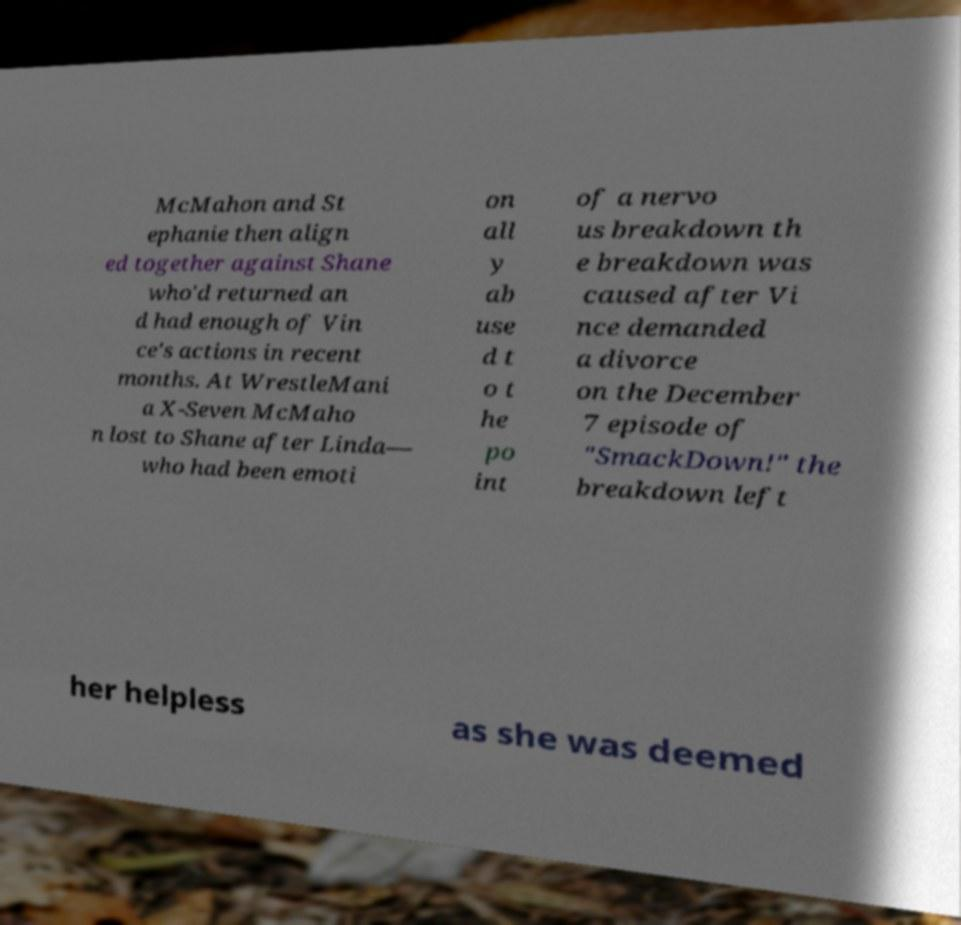Please identify and transcribe the text found in this image. McMahon and St ephanie then align ed together against Shane who'd returned an d had enough of Vin ce's actions in recent months. At WrestleMani a X-Seven McMaho n lost to Shane after Linda— who had been emoti on all y ab use d t o t he po int of a nervo us breakdown th e breakdown was caused after Vi nce demanded a divorce on the December 7 episode of "SmackDown!" the breakdown left her helpless as she was deemed 